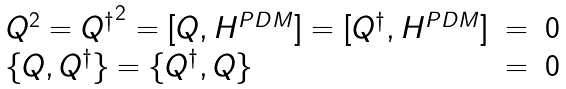Convert formula to latex. <formula><loc_0><loc_0><loc_500><loc_500>\begin{array} { l c l } Q ^ { 2 } = { Q ^ { \dagger } } ^ { 2 } = [ Q , H ^ { P D M } ] = [ Q ^ { \dagger } , H ^ { P D M } ] & = & 0 \\ \{ Q , Q ^ { \dagger } \} = \{ Q ^ { \dagger } , Q \} & = & 0 \end{array}</formula> 